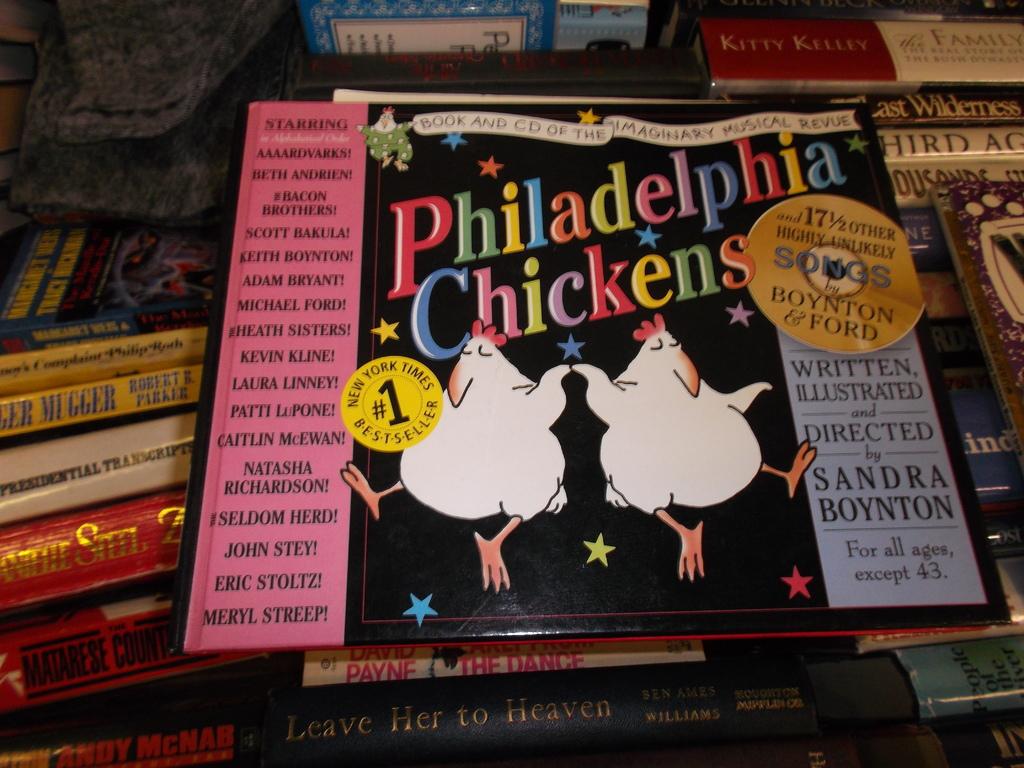What age is this piece not recommended for?
Offer a terse response. 43. What is the title?
Offer a very short reply. Philadelphia chickens. 